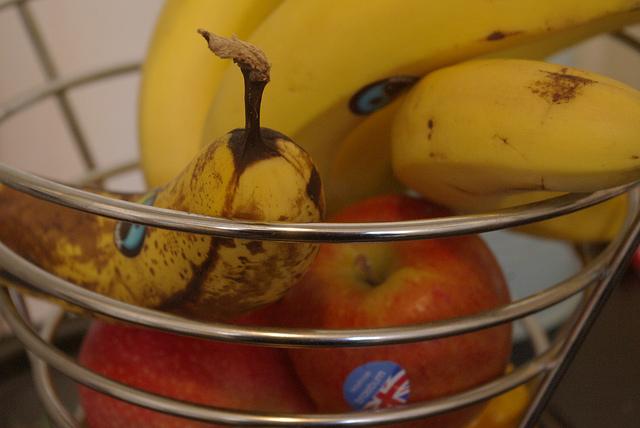Which of these fruits provides the most vitamin C?
Be succinct. Apple. Would this food item be considered vegan?
Write a very short answer. Yes. How many types of fruits?
Give a very brief answer. 2. IS the bowl glass?
Write a very short answer. No. What kind of fruit is in the bucket?
Answer briefly. Bananas and apples. Could you make an apple pie with these apples?
Give a very brief answer. Yes. Is the bowl glass?
Concise answer only. No. What is bowl made of?
Keep it brief. Metal. What country's flag is represented on the sticker of the apple?
Be succinct. England. Which banana has more nutrition?
Quick response, please. All of them. Do the apples have stickers on them?
Concise answer only. Yes. 